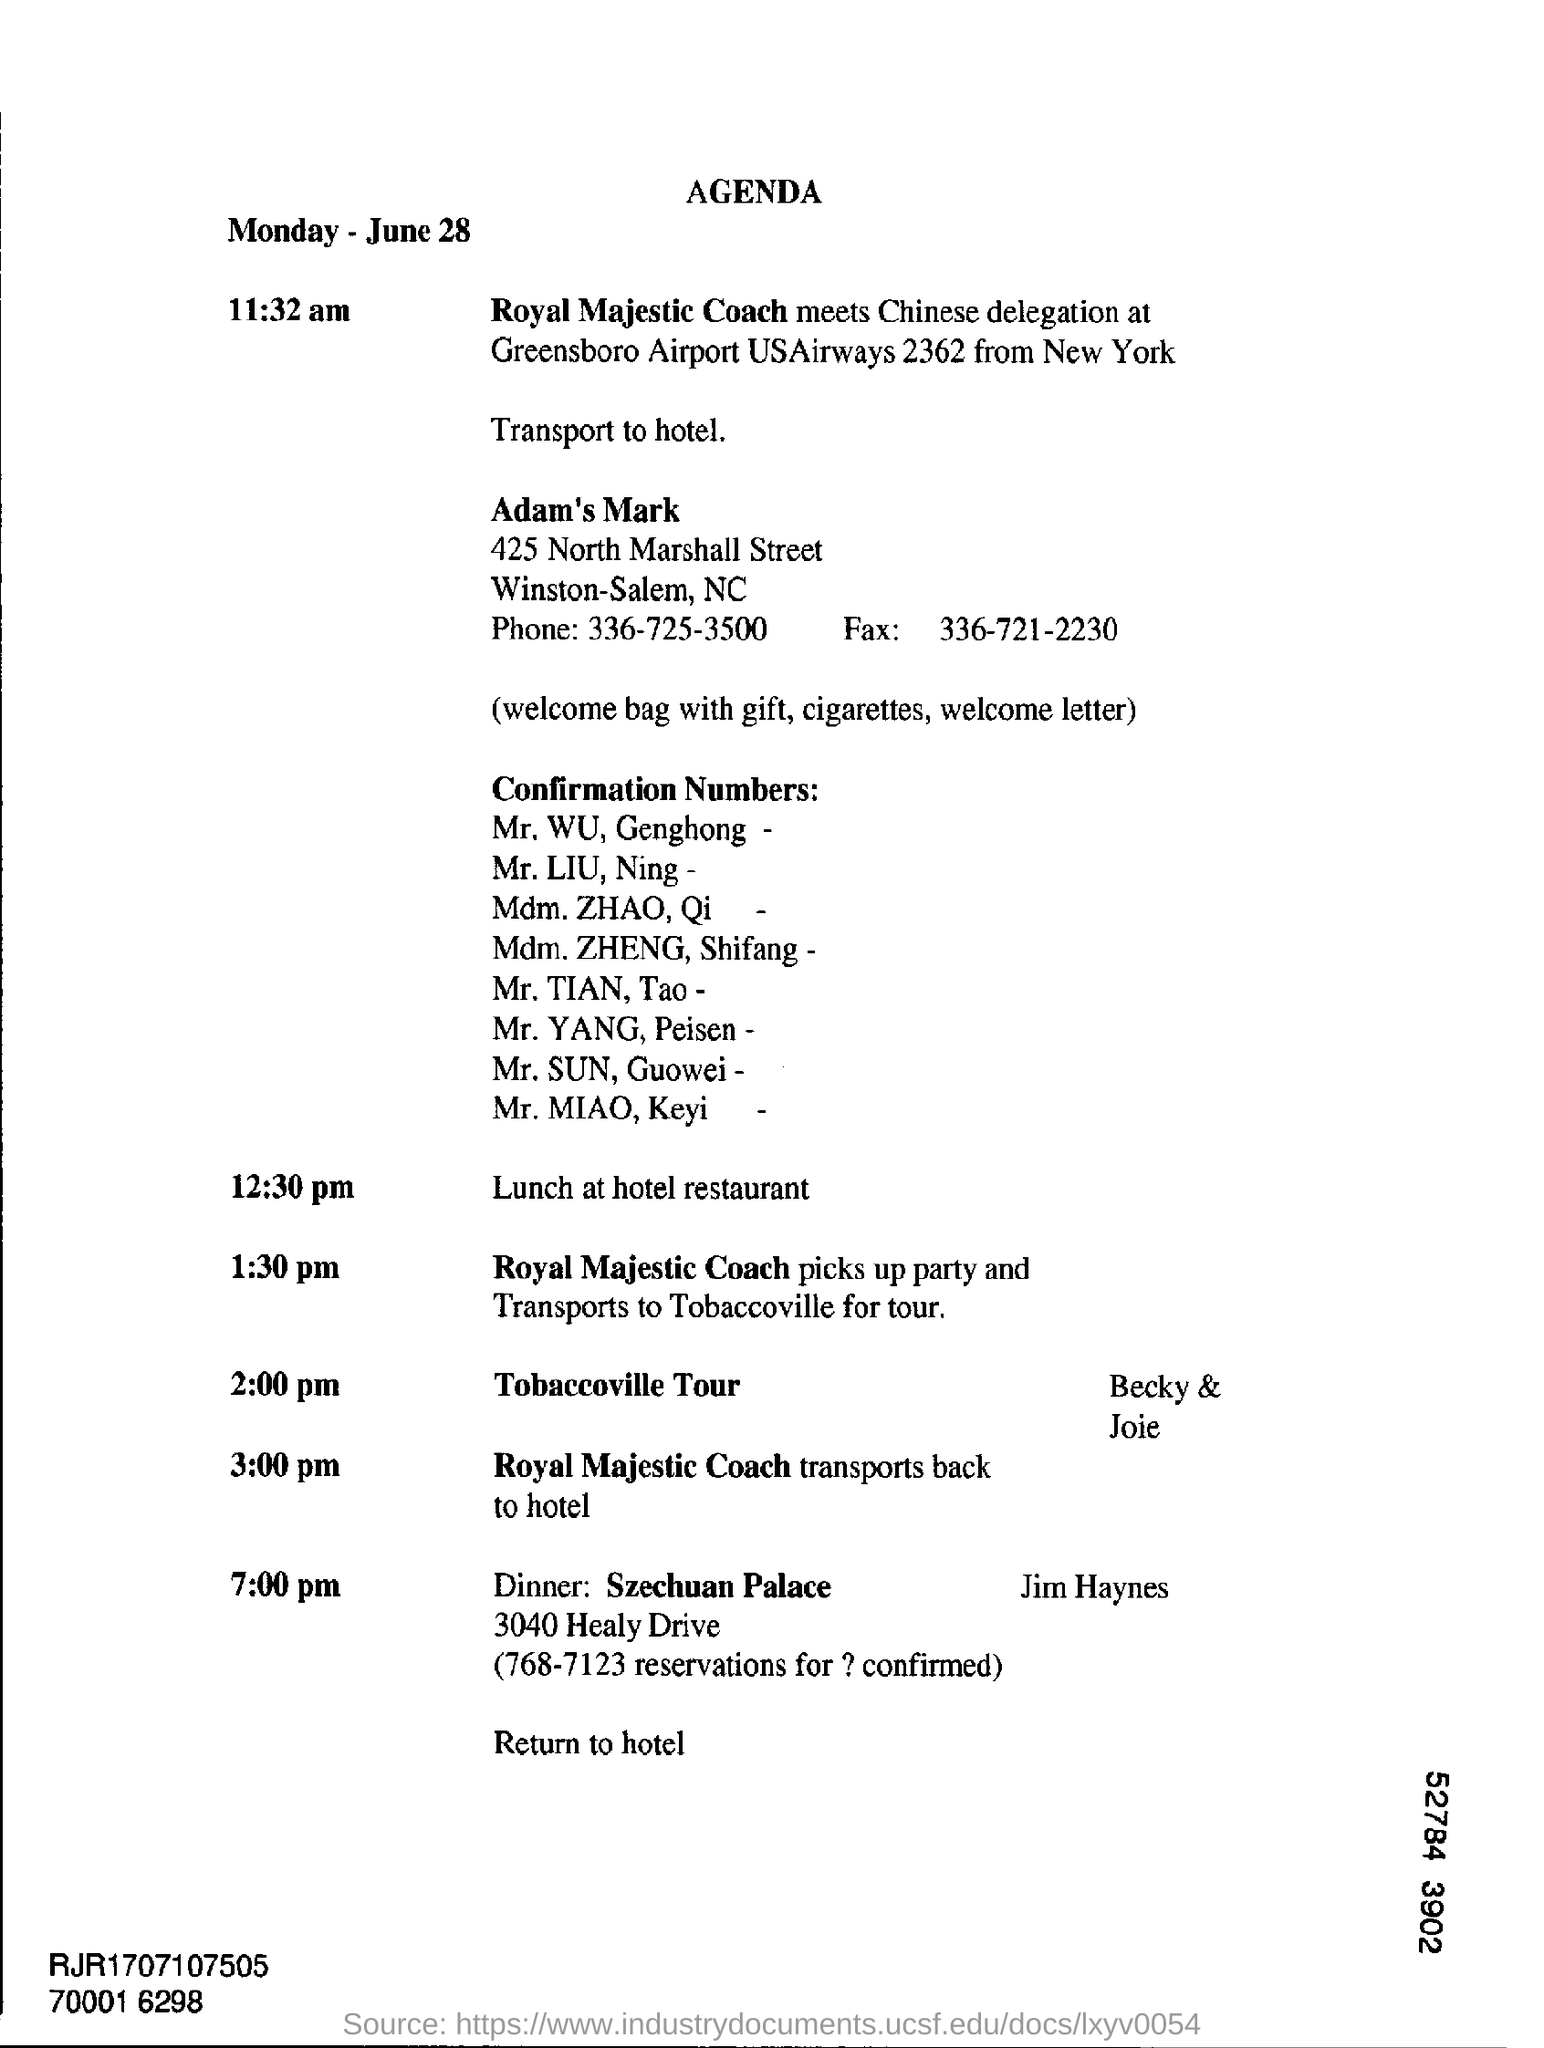Point out several critical features in this image. At 12:30 pm, the schedule is as follows: lunch will be held at the hotel restaurant. 